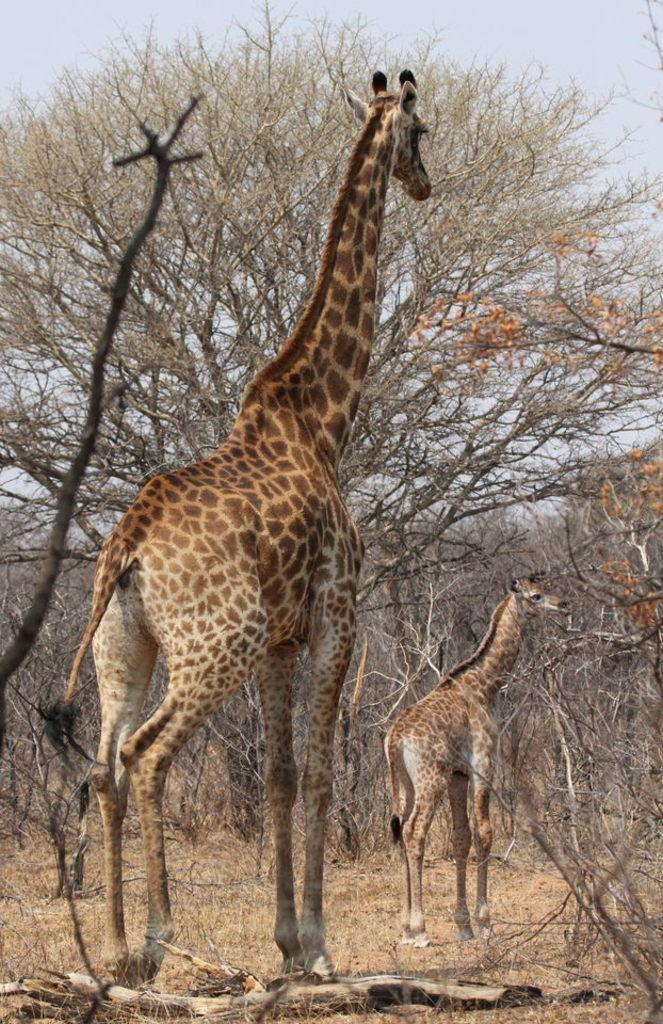How many giraffes are in the image? There are two giraffes in the image. What are the giraffes doing in the image? The giraffes are standing in the image. What type of vegetation is present in the image? There are trees and grass in the image. What can be seen at the top of the image? The sky is visible at the top of the image. What else is visible in the image besides the giraffes and vegetation? Tree branches are present in the image. Can you see a train in the image? No, there is no train present in the image. 